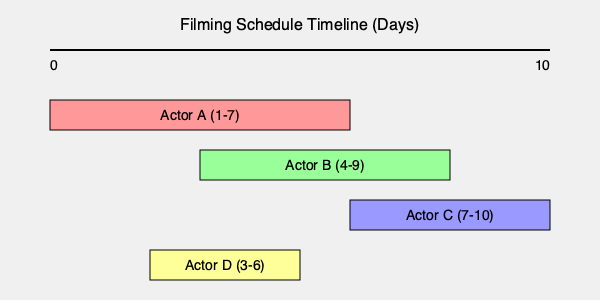As a television producer, you're arranging a filming schedule for a new series. Given the availability of four actors as shown in the timeline, what is the maximum number of consecutive days you can schedule filming with at least two actors available each day? To find the maximum number of consecutive days with at least two actors available, we need to analyze the overlapping periods:

1. Convert the timeline into discrete days:
   Actor A: Days 1-7
   Actor B: Days 4-9
   Actor C: Days 7-10
   Actor D: Days 3-6

2. Count the number of available actors for each day:
   Day 1-2: 1 actor (A)
   Day 3: 2 actors (A, D)
   Day 4-6: 3 actors (A, B, D)
   Day 7: 3 actors (A, B, C)
   Day 8-9: 2 actors (B, C)
   Day 10: 1 actor (C)

3. Identify the longest streak of days with at least 2 actors:
   The streak starts on Day 3 and ends on Day 9, which is 7 consecutive days.

Therefore, the maximum number of consecutive days you can schedule filming with at least two actors available is 7 days.
Answer: 7 days 